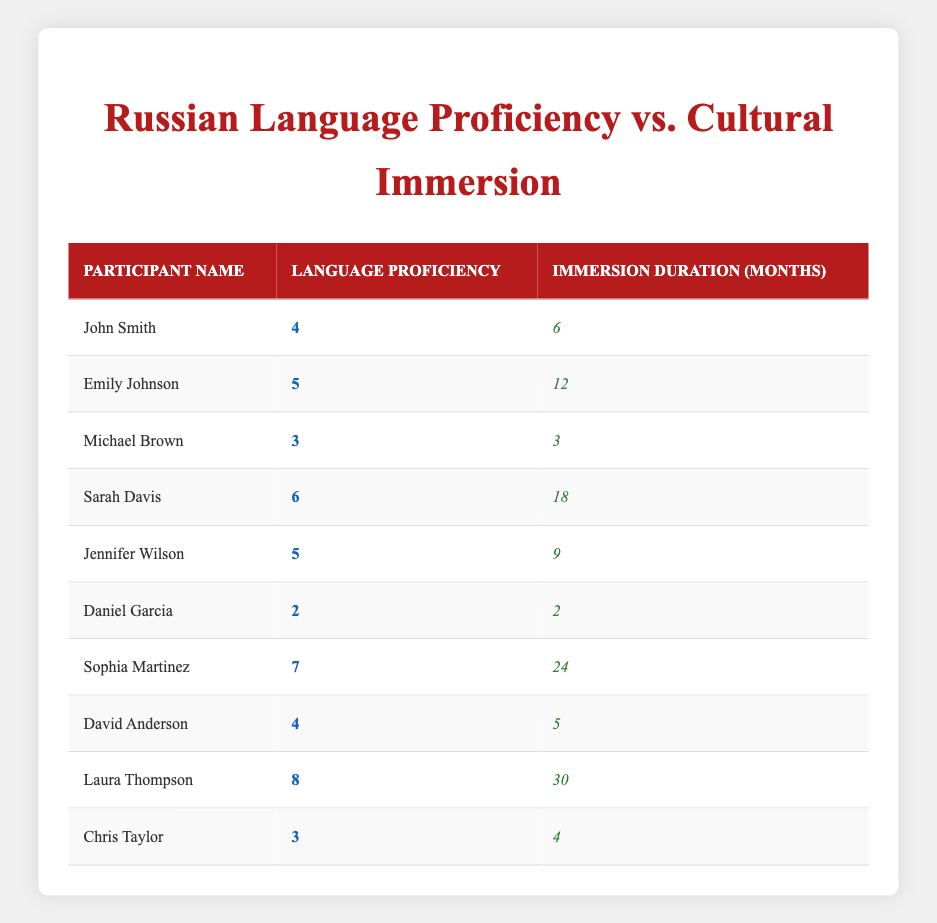What is the highest language proficiency score in the table? Looking through the language proficiency column, the highest score is 8, which is associated with Laura Thompson.
Answer: 8 How many participants had an immersion duration of more than 10 months? By examining the immersion duration column, we find that Emily Johnson (12 months), Sarah Davis (18 months), Sophia Martinez (24 months), and Laura Thompson (30 months) meet this criterion. This gives us a total of 4 participants.
Answer: 4 Which participant had the lowest immersion duration and what was their language proficiency? Daniel Garcia had the lowest immersion duration at 2 months, and his language proficiency score is 2.
Answer: Daniel Garcia, 2 Is there a participant with a language proficiency score of 5 who did not have a cultural immersion duration of at least 10 months? Emily Johnson has a language proficiency score of 5 with an immersion duration of 12 months, while Jennifer Wilson also has a score of 5 but with 9 months of immersion. Therefore, there is one participant, Jennifer Wilson, who fits this criterion.
Answer: Yes What is the average language proficiency of participants with an immersion duration of less than 6 months? The participants with immersion durations less than 6 months are Michael Brown (3 months, proficiency 3), Daniel Garcia (2 months, proficiency 2), and Chris Taylor (4 months, proficiency 3). The average is calculated as (3 + 2 + 3)/3 = 8/3 = 2.67, which is approximately 2.67.
Answer: 2.67 How many participants have a language proficiency above 5? Reviewing the language proficiency scores, Sarah Davis (6), Sophia Martinez (7), and Laura Thompson (8) have scores above 5. This totals 3 participants.
Answer: 3 What is the total duration of immersion experiences for all participants? By summing the immersion durations: 6 + 12 + 3 + 18 + 9 + 2 + 24 + 5 + 30 + 4 = 113 months.
Answer: 113 Which participants have both high language proficiency and long immersion durations? Both Sophia Martinez (7 proficiency, 24 months immersion) and Laura Thompson (8 proficiency, 30 months immersion) qualify as they possess high proficiency (above 5) and long immersion duration (above 12 months).
Answer: Sophia Martinez and Laura Thompson Does any participant have a language proficiency score of 4 and what is their immersion duration? Yes, two participants have a language proficiency score of 4: John Smith (6 months) and David Anderson (5 months).
Answer: Yes, 6 and 5 months 